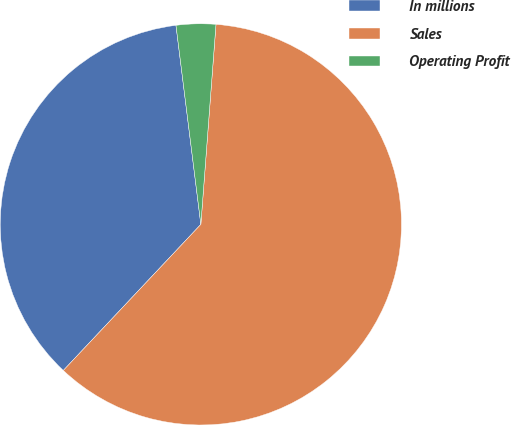Convert chart to OTSL. <chart><loc_0><loc_0><loc_500><loc_500><pie_chart><fcel>In millions<fcel>Sales<fcel>Operating Profit<nl><fcel>36.0%<fcel>60.82%<fcel>3.18%<nl></chart> 